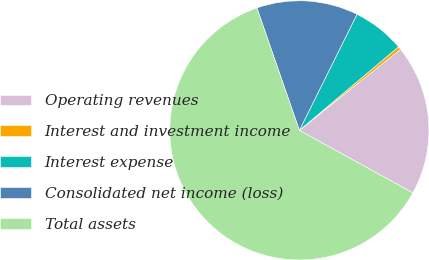Convert chart to OTSL. <chart><loc_0><loc_0><loc_500><loc_500><pie_chart><fcel>Operating revenues<fcel>Interest and investment income<fcel>Interest expense<fcel>Consolidated net income (loss)<fcel>Total assets<nl><fcel>18.77%<fcel>0.39%<fcel>6.52%<fcel>12.65%<fcel>61.67%<nl></chart> 